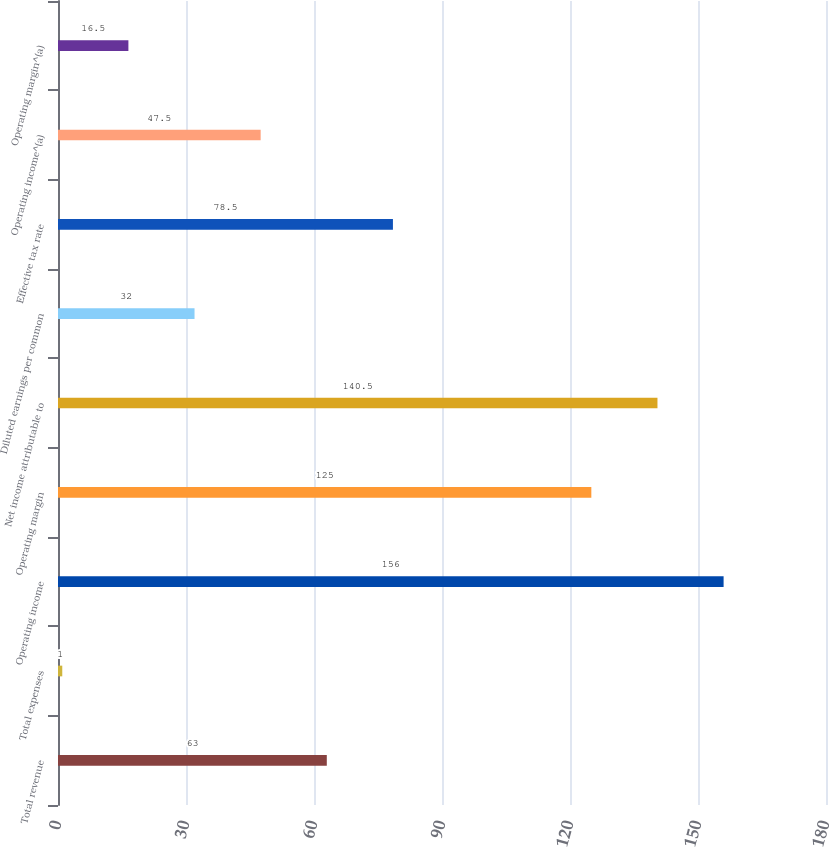Convert chart. <chart><loc_0><loc_0><loc_500><loc_500><bar_chart><fcel>Total revenue<fcel>Total expenses<fcel>Operating income<fcel>Operating margin<fcel>Net income attributable to<fcel>Diluted earnings per common<fcel>Effective tax rate<fcel>Operating income^(a)<fcel>Operating margin^(a)<nl><fcel>63<fcel>1<fcel>156<fcel>125<fcel>140.5<fcel>32<fcel>78.5<fcel>47.5<fcel>16.5<nl></chart> 